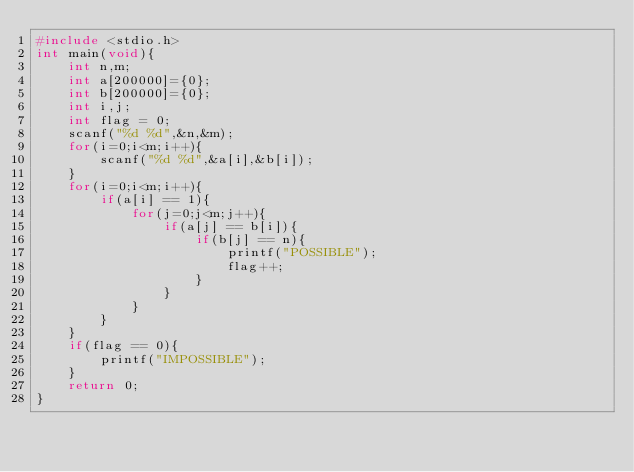<code> <loc_0><loc_0><loc_500><loc_500><_C_>#include <stdio.h>
int main(void){
    int n,m;
    int a[200000]={0};
    int b[200000]={0};
    int i,j;
    int flag = 0;
    scanf("%d %d",&n,&m);
    for(i=0;i<m;i++){
        scanf("%d %d",&a[i],&b[i]);
    }
    for(i=0;i<m;i++){
        if(a[i] == 1){
            for(j=0;j<m;j++){
                if(a[j] == b[i]){
                    if(b[j] == n){
                        printf("POSSIBLE");
                        flag++;
                    }
                }
            }
        }
    }
    if(flag == 0){
        printf("IMPOSSIBLE");
    }
    return 0;
}</code> 